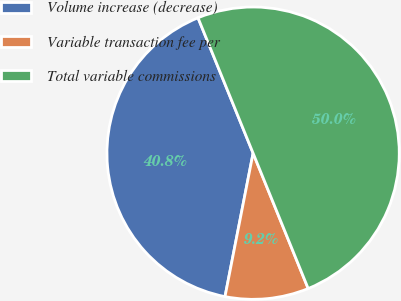<chart> <loc_0><loc_0><loc_500><loc_500><pie_chart><fcel>Volume increase (decrease)<fcel>Variable transaction fee per<fcel>Total variable commissions<nl><fcel>40.77%<fcel>9.23%<fcel>50.0%<nl></chart> 